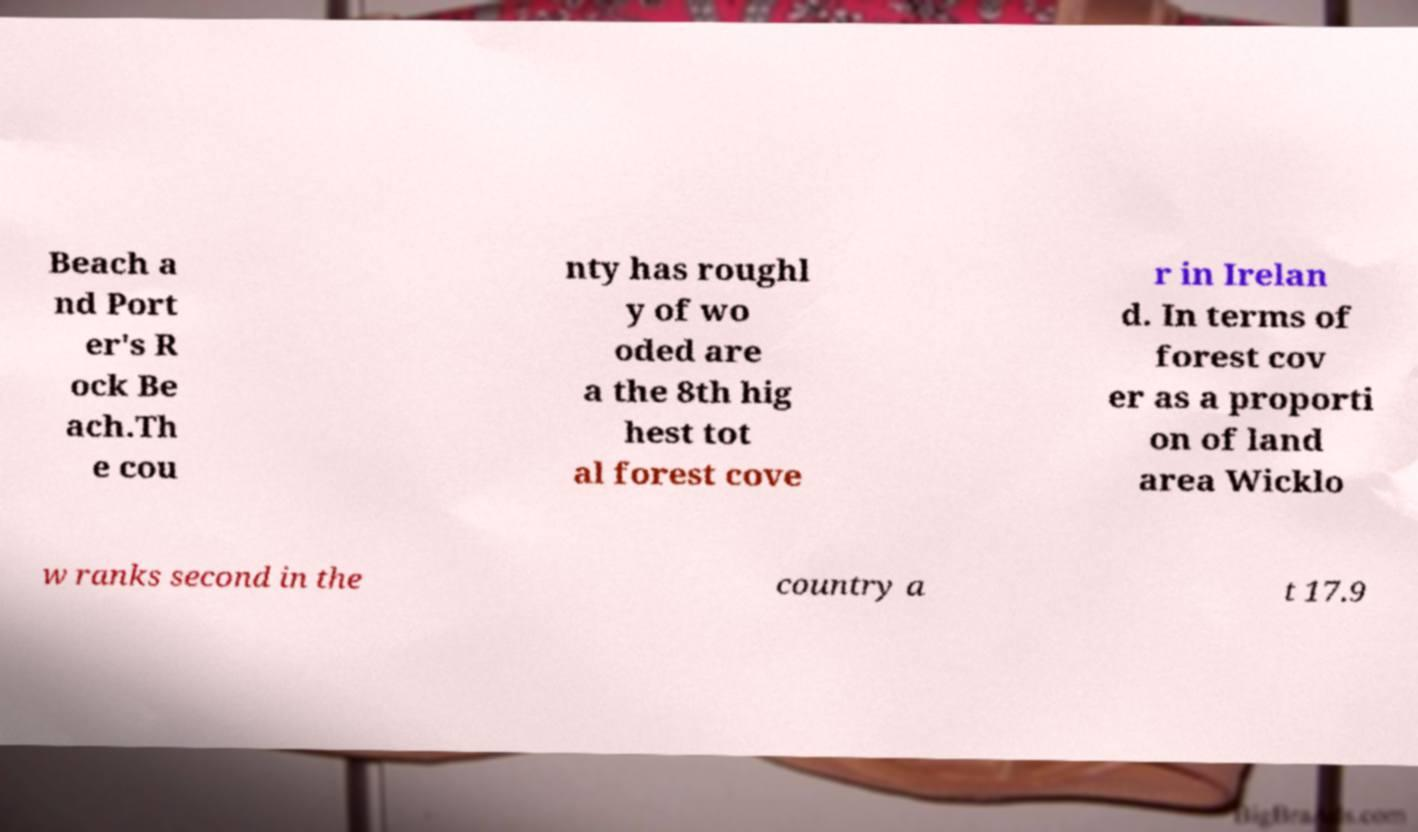I need the written content from this picture converted into text. Can you do that? Beach a nd Port er's R ock Be ach.Th e cou nty has roughl y of wo oded are a the 8th hig hest tot al forest cove r in Irelan d. In terms of forest cov er as a proporti on of land area Wicklo w ranks second in the country a t 17.9 